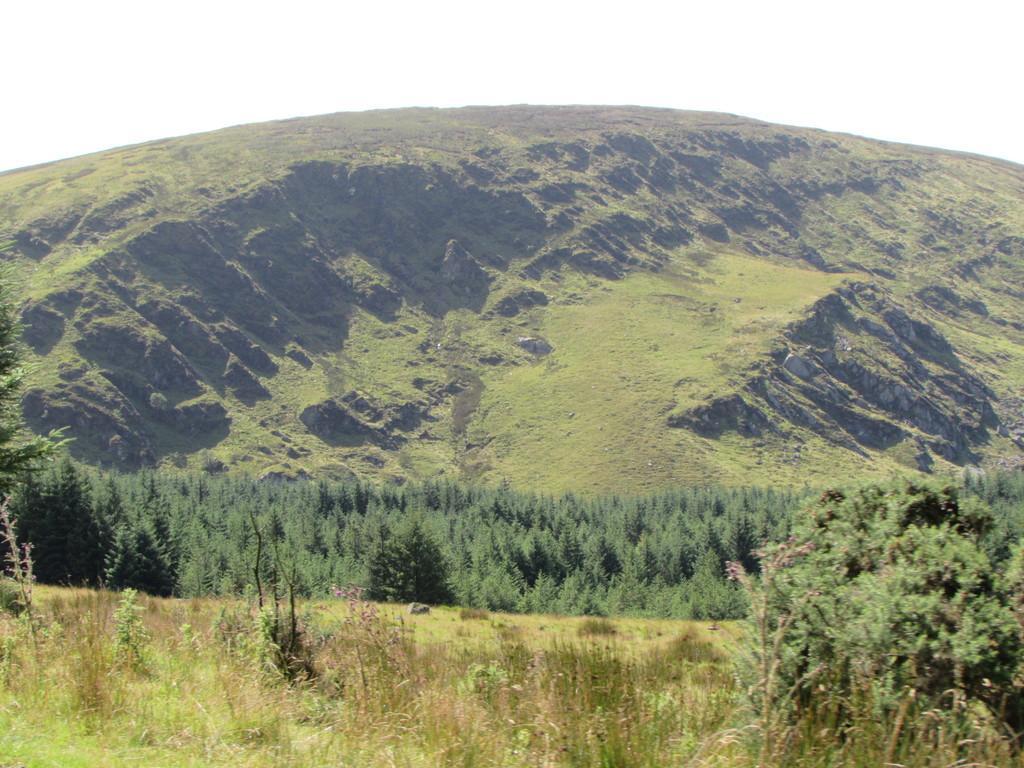Describe this image in one or two sentences. In the image we can see the area is covered with lot of trees and grass. 